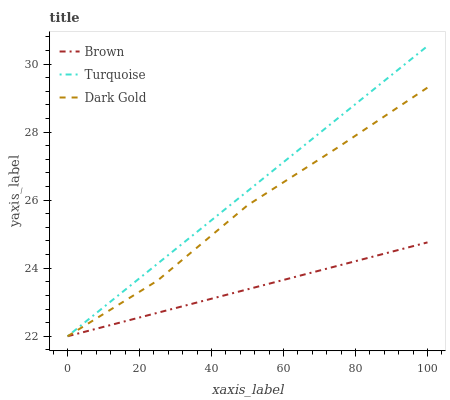Does Brown have the minimum area under the curve?
Answer yes or no. Yes. Does Turquoise have the maximum area under the curve?
Answer yes or no. Yes. Does Dark Gold have the minimum area under the curve?
Answer yes or no. No. Does Dark Gold have the maximum area under the curve?
Answer yes or no. No. Is Brown the smoothest?
Answer yes or no. Yes. Is Dark Gold the roughest?
Answer yes or no. Yes. Is Turquoise the smoothest?
Answer yes or no. No. Is Turquoise the roughest?
Answer yes or no. No. Does Brown have the lowest value?
Answer yes or no. Yes. Does Turquoise have the highest value?
Answer yes or no. Yes. Does Dark Gold have the highest value?
Answer yes or no. No. Does Dark Gold intersect Brown?
Answer yes or no. Yes. Is Dark Gold less than Brown?
Answer yes or no. No. Is Dark Gold greater than Brown?
Answer yes or no. No. 